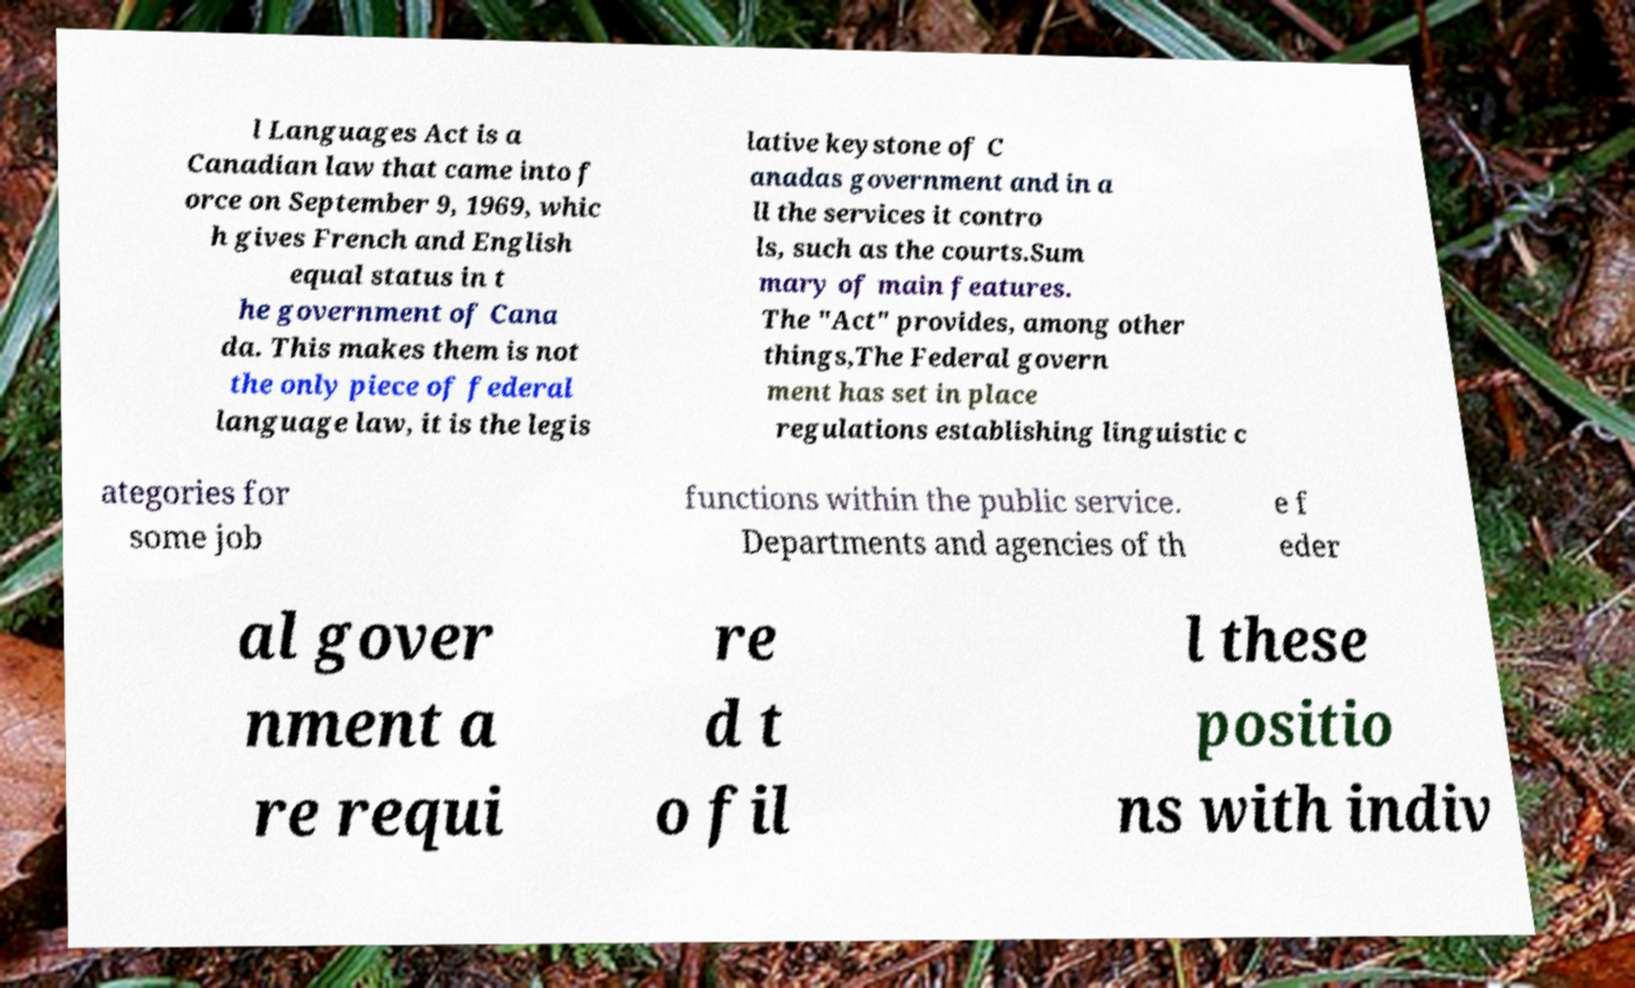I need the written content from this picture converted into text. Can you do that? l Languages Act is a Canadian law that came into f orce on September 9, 1969, whic h gives French and English equal status in t he government of Cana da. This makes them is not the only piece of federal language law, it is the legis lative keystone of C anadas government and in a ll the services it contro ls, such as the courts.Sum mary of main features. The "Act" provides, among other things,The Federal govern ment has set in place regulations establishing linguistic c ategories for some job functions within the public service. Departments and agencies of th e f eder al gover nment a re requi re d t o fil l these positio ns with indiv 